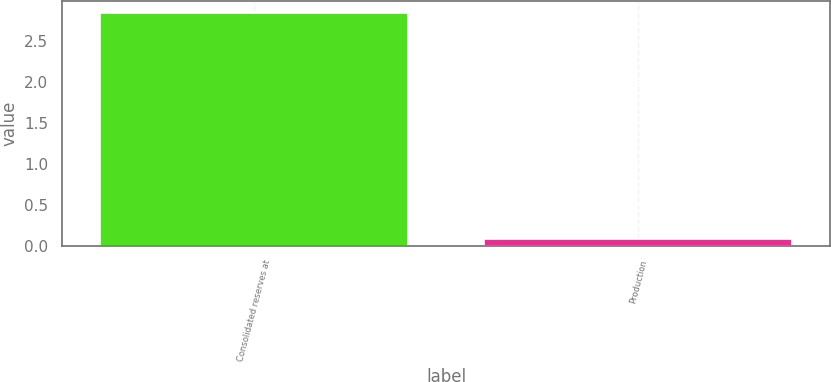Convert chart. <chart><loc_0><loc_0><loc_500><loc_500><bar_chart><fcel>Consolidated reserves at<fcel>Production<nl><fcel>2.84<fcel>0.08<nl></chart> 